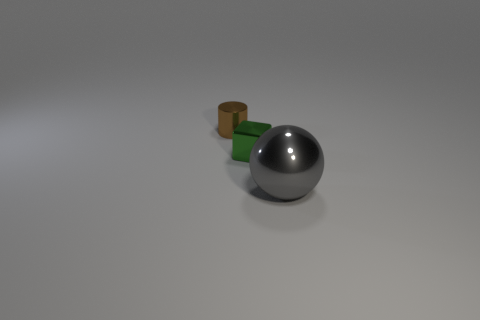Is there anything else that has the same size as the gray metal thing?
Provide a short and direct response. No. Is the material of the tiny cube the same as the object that is right of the green metal block?
Your answer should be compact. Yes. There is a block that is made of the same material as the large thing; what size is it?
Give a very brief answer. Small. There is a shiny thing on the left side of the shiny cube; what is its size?
Keep it short and to the point. Small. How many other brown metallic cylinders are the same size as the brown cylinder?
Ensure brevity in your answer.  0. Is there a large thing that has the same color as the cylinder?
Ensure brevity in your answer.  No. There is a metal cylinder that is the same size as the green shiny thing; what is its color?
Your answer should be very brief. Brown. There is a tiny shiny block; is it the same color as the object in front of the small green metallic block?
Offer a terse response. No. What color is the ball?
Provide a succinct answer. Gray. What is the material of the tiny object in front of the small metal cylinder?
Your answer should be compact. Metal. 